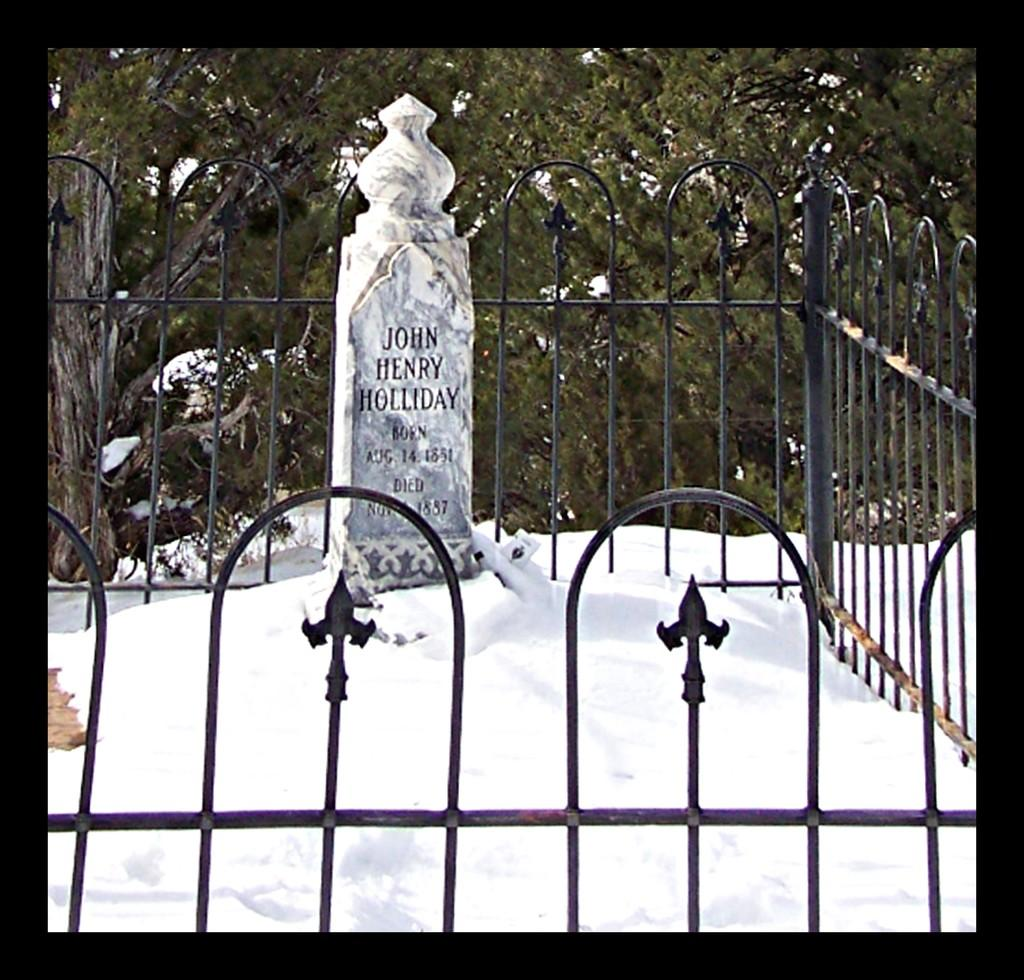What is the main structure in the image? There is a monument in the image. What is the weather condition in the image? There is snow in the image. What is in front of the monument? There is a black color fencing in front of the monument. What can be seen in the distance in the image? There are trees visible in the background of the image. What type of tools does the carpenter use to build the bridge in the image? There is no carpenter or bridge present in the image. What is the monument made of, specifically mentioning zinc? The monument's composition is not mentioned in the facts, and there is no mention of zinc. 